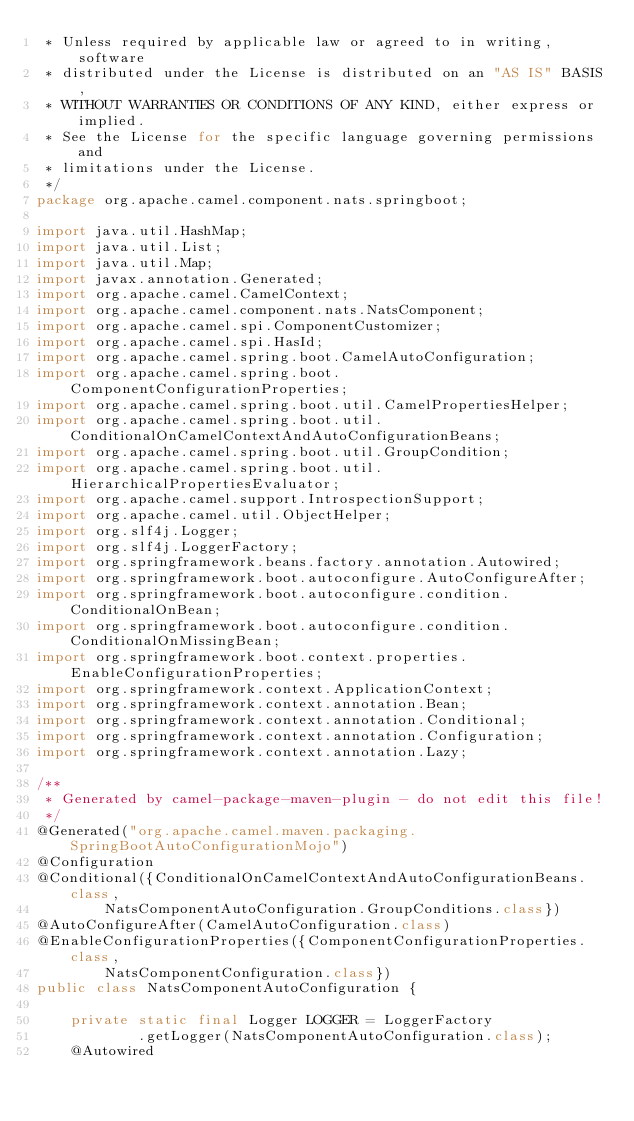<code> <loc_0><loc_0><loc_500><loc_500><_Java_> * Unless required by applicable law or agreed to in writing, software
 * distributed under the License is distributed on an "AS IS" BASIS,
 * WITHOUT WARRANTIES OR CONDITIONS OF ANY KIND, either express or implied.
 * See the License for the specific language governing permissions and
 * limitations under the License.
 */
package org.apache.camel.component.nats.springboot;

import java.util.HashMap;
import java.util.List;
import java.util.Map;
import javax.annotation.Generated;
import org.apache.camel.CamelContext;
import org.apache.camel.component.nats.NatsComponent;
import org.apache.camel.spi.ComponentCustomizer;
import org.apache.camel.spi.HasId;
import org.apache.camel.spring.boot.CamelAutoConfiguration;
import org.apache.camel.spring.boot.ComponentConfigurationProperties;
import org.apache.camel.spring.boot.util.CamelPropertiesHelper;
import org.apache.camel.spring.boot.util.ConditionalOnCamelContextAndAutoConfigurationBeans;
import org.apache.camel.spring.boot.util.GroupCondition;
import org.apache.camel.spring.boot.util.HierarchicalPropertiesEvaluator;
import org.apache.camel.support.IntrospectionSupport;
import org.apache.camel.util.ObjectHelper;
import org.slf4j.Logger;
import org.slf4j.LoggerFactory;
import org.springframework.beans.factory.annotation.Autowired;
import org.springframework.boot.autoconfigure.AutoConfigureAfter;
import org.springframework.boot.autoconfigure.condition.ConditionalOnBean;
import org.springframework.boot.autoconfigure.condition.ConditionalOnMissingBean;
import org.springframework.boot.context.properties.EnableConfigurationProperties;
import org.springframework.context.ApplicationContext;
import org.springframework.context.annotation.Bean;
import org.springframework.context.annotation.Conditional;
import org.springframework.context.annotation.Configuration;
import org.springframework.context.annotation.Lazy;

/**
 * Generated by camel-package-maven-plugin - do not edit this file!
 */
@Generated("org.apache.camel.maven.packaging.SpringBootAutoConfigurationMojo")
@Configuration
@Conditional({ConditionalOnCamelContextAndAutoConfigurationBeans.class,
        NatsComponentAutoConfiguration.GroupConditions.class})
@AutoConfigureAfter(CamelAutoConfiguration.class)
@EnableConfigurationProperties({ComponentConfigurationProperties.class,
        NatsComponentConfiguration.class})
public class NatsComponentAutoConfiguration {

    private static final Logger LOGGER = LoggerFactory
            .getLogger(NatsComponentAutoConfiguration.class);
    @Autowired</code> 